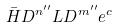Convert formula to latex. <formula><loc_0><loc_0><loc_500><loc_500>\bar { H } D ^ { n ^ { \prime \prime } } L D ^ { m ^ { \prime \prime } } e ^ { c }</formula> 